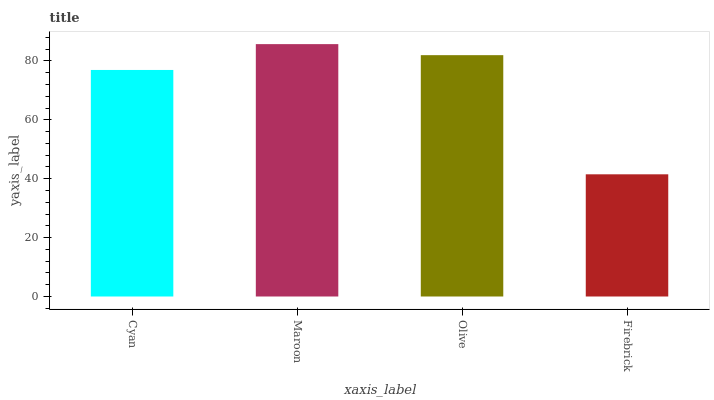Is Firebrick the minimum?
Answer yes or no. Yes. Is Maroon the maximum?
Answer yes or no. Yes. Is Olive the minimum?
Answer yes or no. No. Is Olive the maximum?
Answer yes or no. No. Is Maroon greater than Olive?
Answer yes or no. Yes. Is Olive less than Maroon?
Answer yes or no. Yes. Is Olive greater than Maroon?
Answer yes or no. No. Is Maroon less than Olive?
Answer yes or no. No. Is Olive the high median?
Answer yes or no. Yes. Is Cyan the low median?
Answer yes or no. Yes. Is Cyan the high median?
Answer yes or no. No. Is Maroon the low median?
Answer yes or no. No. 